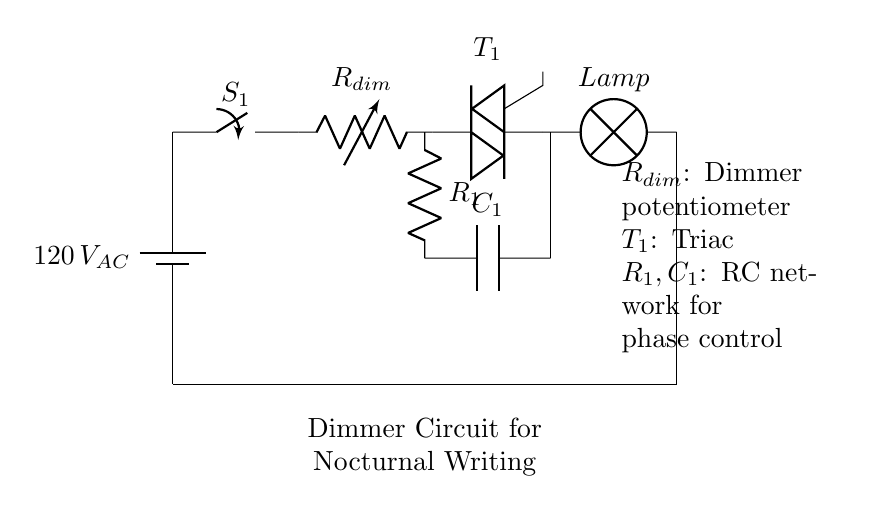What is the main component that dims the light? The main component that dims the light is the variable resistor labeled as R dim. It alters the resistance in the circuit, controlling the current flowing to the lamp.
Answer: R dim What type of switch is used in this circuit? The switch used in this circuit is a standard switch labeled as S1. It allows or interrupts the flow of electricity in the circuit.
Answer: S1 What is the purpose of the triac? The purpose of the triac, labeled as T1, is to control the power flow to the lamp, allowing for phase control in dimming functionality.
Answer: T1 Which components form the RC network? The components forming the RC network are R1 and C1. This network is used for phase control to adjust the brightness of the lamp.
Answer: R1, C1 How does the dimmer affect the power to the lamp? The dimmer affects power by varying the resistance, which changes the amount of current reaching the lamp, thus adjusting brightness.
Answer: By varying resistance What is the supply voltage in this circuit? The supply voltage in this circuit is 120 volts alternating current, indicated next to the battery symbol.
Answer: 120 volts AC What is the expected outcome when adjusting R dim? Adjusting R dim would change the light intensity of the lamp, making it brighter or dimmer based on the setting of the potentiometer.
Answer: Change in light intensity 